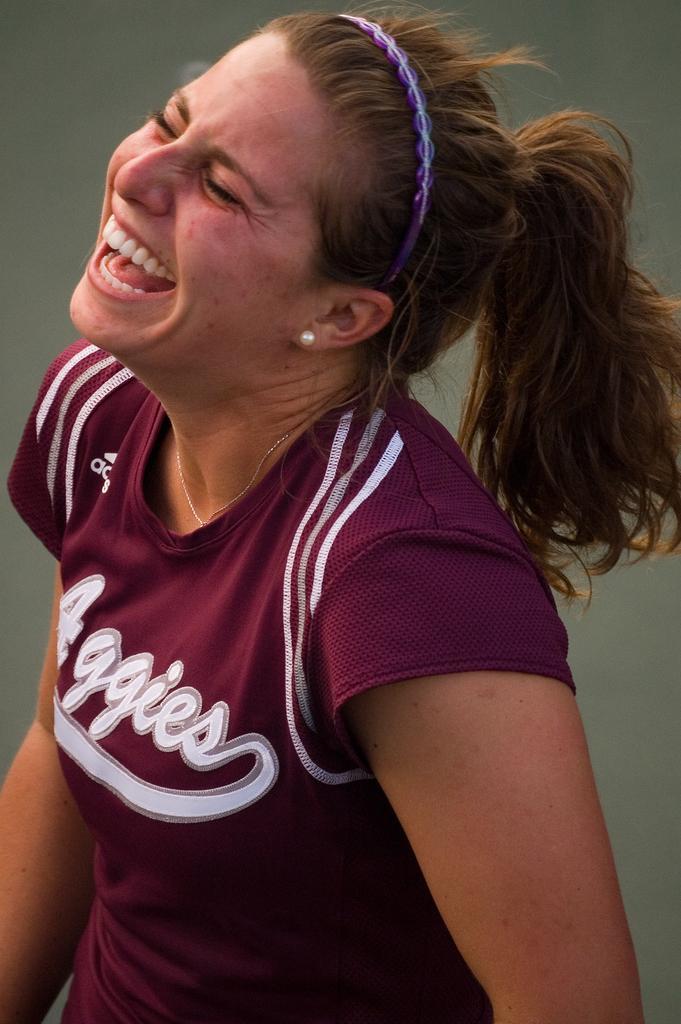Please provide a concise description of this image. In this image, we can see a person wearing clothes. 